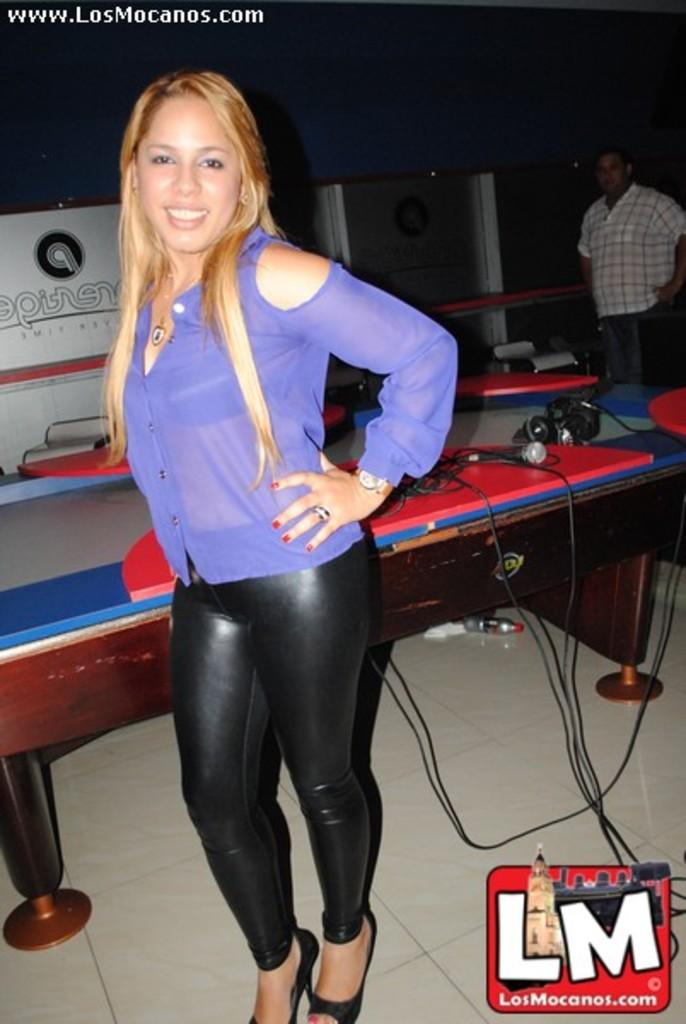What is the woman in the image doing? The woman is standing on the floor and smiling. What can be seen in the background of the image? There is a table in the background. What is on the table? There is a microphone on the table, along with other objects. How many people are present in the image? There is one person standing in the image, which is the woman. What type of quilt is being used to secure the chain in the image? There is no quilt or chain present in the image. 